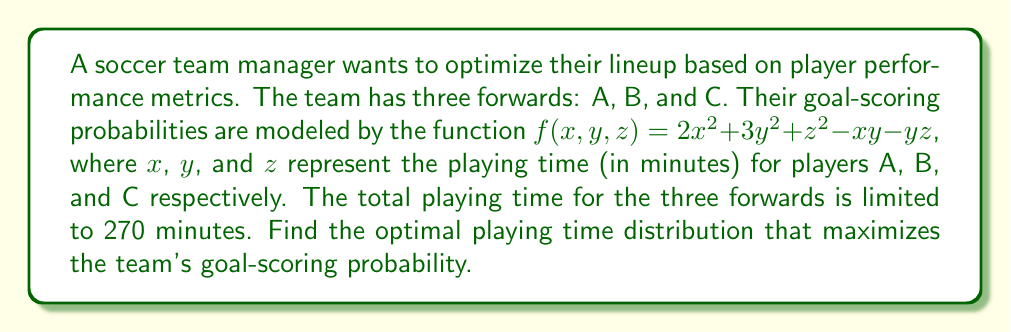What is the answer to this math problem? To solve this optimization problem, we'll use the method of Lagrange multipliers:

1) Define the objective function:
   $f(x, y, z) = 2x^2 + 3y^2 + z^2 - xy - yz$

2) Define the constraint:
   $g(x, y, z) = x + y + z - 270 = 0$

3) Form the Lagrangian:
   $L(x, y, z, \lambda) = f(x, y, z) - \lambda g(x, y, z)$
   $L(x, y, z, \lambda) = 2x^2 + 3y^2 + z^2 - xy - yz - \lambda(x + y + z - 270)$

4) Take partial derivatives and set them to zero:
   $\frac{\partial L}{\partial x} = 4x - y - \lambda = 0$
   $\frac{\partial L}{\partial y} = 6y - x - z - \lambda = 0$
   $\frac{\partial L}{\partial z} = 2z - y - \lambda = 0$
   $\frac{\partial L}{\partial \lambda} = x + y + z - 270 = 0$

5) Solve the system of equations:
   From (1) and (3): $4x - y = 2z - y$, so $4x = 2z$, or $x = \frac{1}{2}z$
   From (2) and (3): $6y - x - z = 2z - y$, so $7y = 3z + x = 3z + \frac{1}{2}z = \frac{7}{2}z$, or $y = \frac{1}{2}z$
   
   Substituting into the constraint equation:
   $\frac{1}{2}z + \frac{1}{2}z + z = 270$
   $2z = 270$
   $z = 135$

   Therefore, $x = \frac{1}{2}(135) = 67.5$ and $y = \frac{1}{2}(135) = 67.5$

6) Verify that this is a maximum using the second derivative test (omitted for brevity).
Answer: Player A: 67.5 minutes, Player B: 67.5 minutes, Player C: 135 minutes 